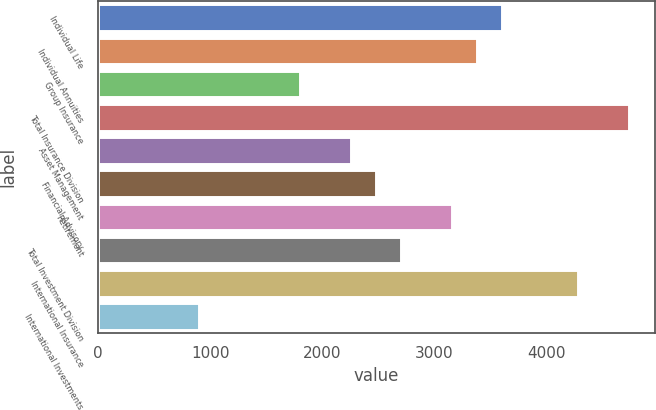Convert chart. <chart><loc_0><loc_0><loc_500><loc_500><bar_chart><fcel>Individual Life<fcel>Individual Annuities<fcel>Group Insurance<fcel>Total Insurance Division<fcel>Asset Management<fcel>Financial Advisory<fcel>Retirement<fcel>Total Investment Division<fcel>International Insurance<fcel>International Investments<nl><fcel>3607.63<fcel>3382.36<fcel>1805.47<fcel>4733.98<fcel>2256.01<fcel>2481.28<fcel>3157.09<fcel>2706.55<fcel>4283.44<fcel>904.39<nl></chart> 